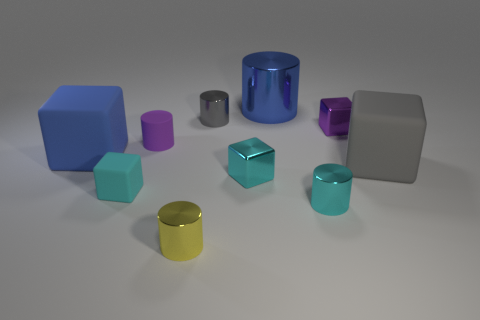What is the object that is to the left of the small cube that is in front of the small metallic cube that is on the left side of the big blue cylinder made of?
Your answer should be compact. Rubber. There is a gray thing that is made of the same material as the big blue cube; what is its size?
Give a very brief answer. Large. Are there any other objects that have the same color as the big metallic object?
Offer a terse response. Yes. Is the size of the blue metal cylinder the same as the gray shiny object behind the large gray rubber cube?
Offer a very short reply. No. There is a blue cylinder that is left of the small purple object that is on the right side of the gray metal cylinder; how many things are right of it?
Make the answer very short. 3. What is the size of the object that is the same color as the big shiny cylinder?
Your response must be concise. Large. Are there any yellow shiny objects left of the cyan metal cylinder?
Offer a terse response. Yes. What is the shape of the gray matte object?
Provide a succinct answer. Cube. There is a gray object that is in front of the blue object in front of the small purple thing right of the large metal cylinder; what shape is it?
Provide a succinct answer. Cube. How many other objects are the same shape as the blue rubber object?
Your answer should be compact. 4. 